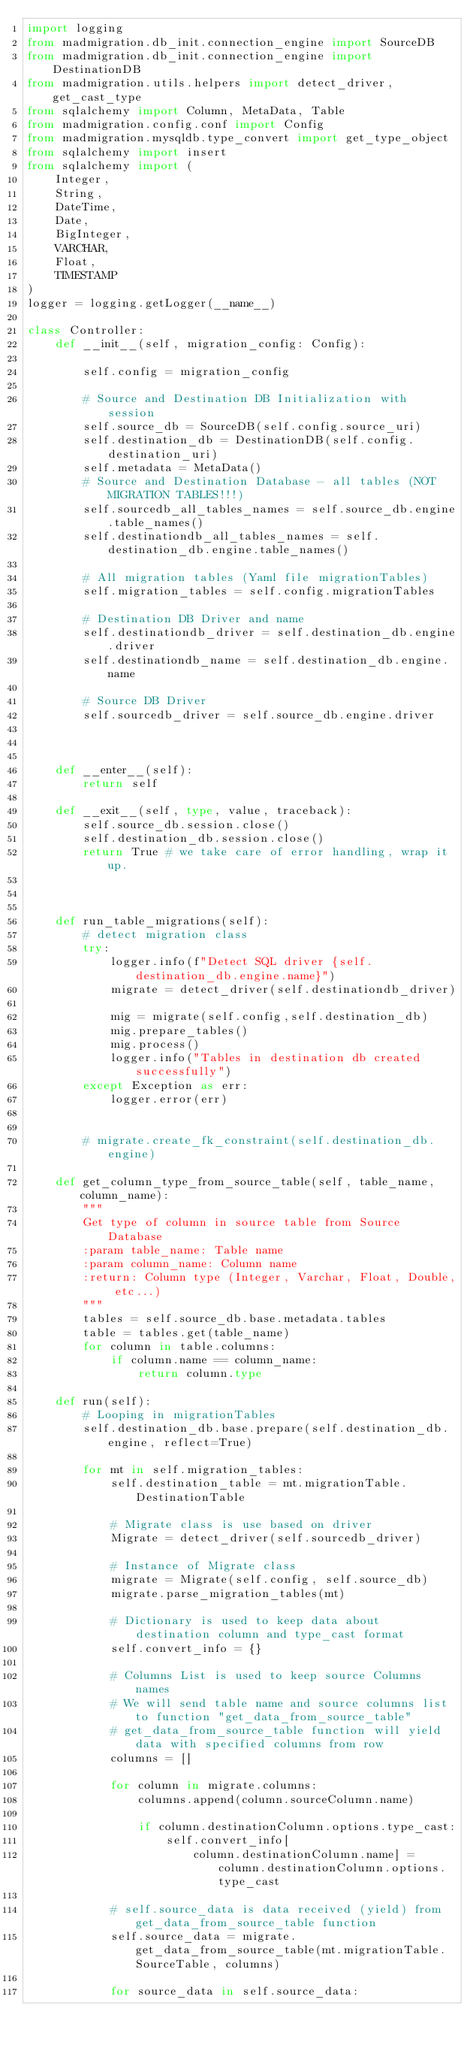Convert code to text. <code><loc_0><loc_0><loc_500><loc_500><_Python_>import logging
from madmigration.db_init.connection_engine import SourceDB
from madmigration.db_init.connection_engine import DestinationDB
from madmigration.utils.helpers import detect_driver, get_cast_type
from sqlalchemy import Column, MetaData, Table
from madmigration.config.conf import Config
from madmigration.mysqldb.type_convert import get_type_object
from sqlalchemy import insert
from sqlalchemy import (
    Integer,
    String,
    DateTime,
    Date,
    BigInteger,
    VARCHAR,
    Float,
    TIMESTAMP
)
logger = logging.getLogger(__name__)

class Controller:
    def __init__(self, migration_config: Config):
        
        self.config = migration_config

        # Source and Destination DB Initialization with session
        self.source_db = SourceDB(self.config.source_uri)
        self.destination_db = DestinationDB(self.config.destination_uri)
        self.metadata = MetaData()
        # Source and Destination Database - all tables (NOT MIGRATION TABLES!!!)
        self.sourcedb_all_tables_names = self.source_db.engine.table_names()
        self.destinationdb_all_tables_names = self.destination_db.engine.table_names()

        # All migration tables (Yaml file migrationTables)
        self.migration_tables = self.config.migrationTables

        # Destination DB Driver and name
        self.destinationdb_driver = self.destination_db.engine.driver
        self.destinationdb_name = self.destination_db.engine.name

        # Source DB Driver
        self.sourcedb_driver = self.source_db.engine.driver

    

    def __enter__(self):
        return self

    def __exit__(self, type, value, traceback):
        self.source_db.session.close()
        self.destination_db.session.close()
        return True # we take care of error handling, wrap it up.

    

    def run_table_migrations(self):
        # detect migration class
        try:
            logger.info(f"Detect SQL driver {self.destination_db.engine.name}")
            migrate = detect_driver(self.destinationdb_driver)
            
            mig = migrate(self.config,self.destination_db)
            mig.prepare_tables()
            mig.process()
            logger.info("Tables in destination db created successfully")
        except Exception as err:
            logger.error(err)
            
        
        # migrate.create_fk_constraint(self.destination_db.engine)

    def get_column_type_from_source_table(self, table_name, column_name):
        """
        Get type of column in source table from Source Database
        :param table_name: Table name
        :param column_name: Column name
        :return: Column type (Integer, Varchar, Float, Double, etc...)
        """
        tables = self.source_db.base.metadata.tables
        table = tables.get(table_name)
        for column in table.columns:
            if column.name == column_name:
                return column.type

    def run(self):
        # Looping in migrationTables
        self.destination_db.base.prepare(self.destination_db.engine, reflect=True)

        for mt in self.migration_tables:
            self.destination_table = mt.migrationTable.DestinationTable

            # Migrate class is use based on driver
            Migrate = detect_driver(self.sourcedb_driver)
            
            # Instance of Migrate class
            migrate = Migrate(self.config, self.source_db)
            migrate.parse_migration_tables(mt) 

            # Dictionary is used to keep data about destination column and type_cast format
            self.convert_info = {}

            # Columns List is used to keep source Columns names
            # We will send table name and source columns list to function "get_data_from_source_table"
            # get_data_from_source_table function will yield data with specified columns from row
            columns = []
            
            for column in migrate.columns:
                columns.append(column.sourceColumn.name)

                if column.destinationColumn.options.type_cast:
                    self.convert_info[
                        column.destinationColumn.name] = column.destinationColumn.options.type_cast
            
            # self.source_data is data received (yield) from get_data_from_source_table function
            self.source_data = migrate.get_data_from_source_table(mt.migrationTable.SourceTable, columns)
            
            for source_data in self.source_data:</code> 